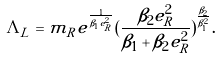<formula> <loc_0><loc_0><loc_500><loc_500>\Lambda _ { L } = m _ { R } e ^ { \frac { 1 } { \beta _ { 1 } e _ { R } ^ { 2 } } } ( \frac { \beta _ { 2 } e _ { R } ^ { 2 } } { \beta _ { 1 } + \beta _ { 2 } e _ { R } ^ { 2 } } ) ^ { \frac { \beta _ { 2 } } { \beta _ { 1 } ^ { 2 } } } .</formula> 